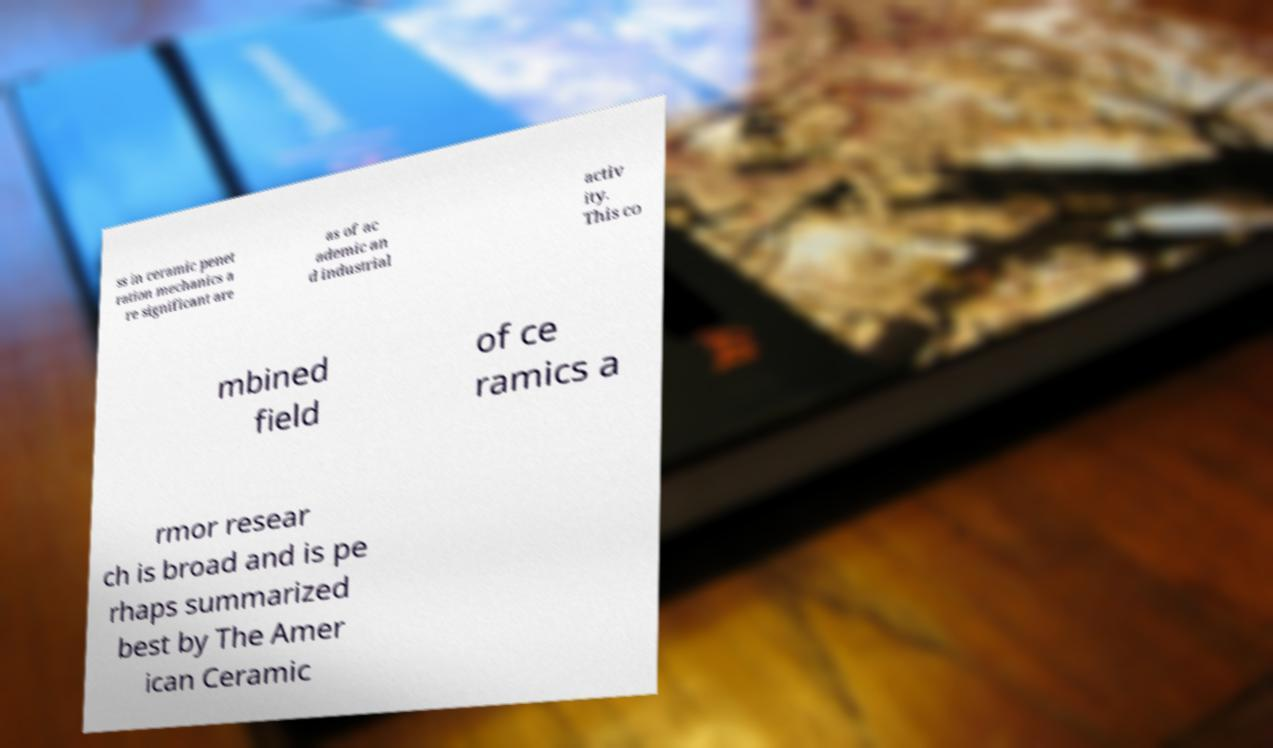For documentation purposes, I need the text within this image transcribed. Could you provide that? ss in ceramic penet ration mechanics a re significant are as of ac ademic an d industrial activ ity. This co mbined field of ce ramics a rmor resear ch is broad and is pe rhaps summarized best by The Amer ican Ceramic 